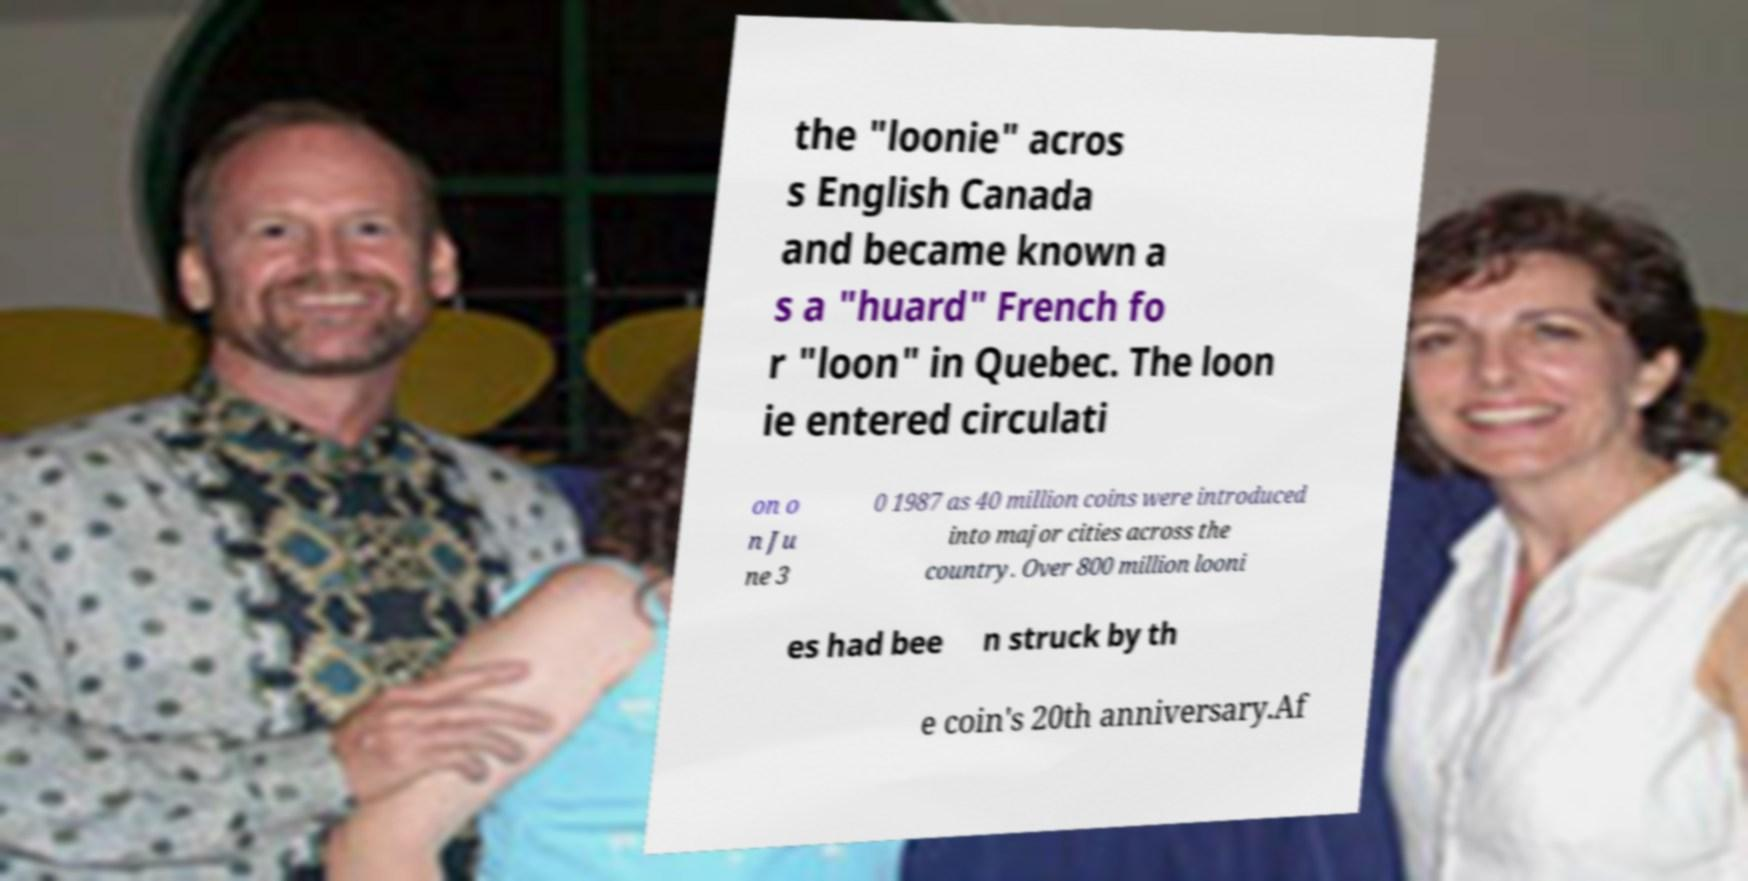Please read and relay the text visible in this image. What does it say? the "loonie" acros s English Canada and became known a s a "huard" French fo r "loon" in Quebec. The loon ie entered circulati on o n Ju ne 3 0 1987 as 40 million coins were introduced into major cities across the country. Over 800 million looni es had bee n struck by th e coin's 20th anniversary.Af 